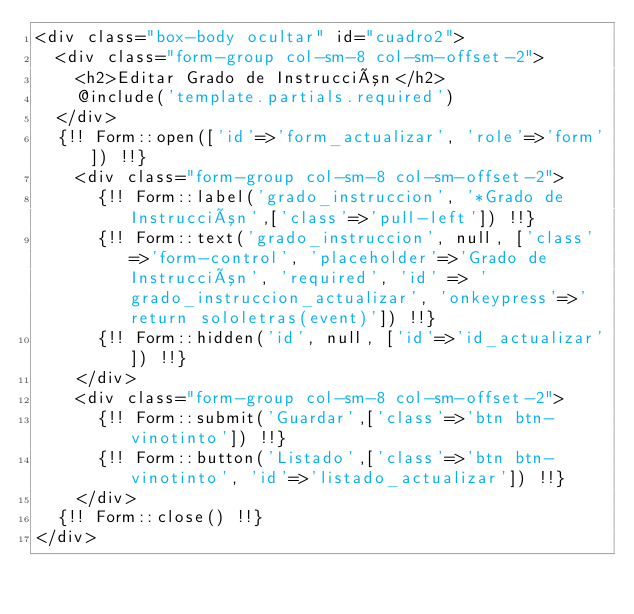Convert code to text. <code><loc_0><loc_0><loc_500><loc_500><_PHP_><div class="box-body ocultar" id="cuadro2">
  <div class="form-group col-sm-8 col-sm-offset-2">
    <h2>Editar Grado de Instrucción</h2>
    @include('template.partials.required')
  </div>
  {!! Form::open(['id'=>'form_actualizar', 'role'=>'form']) !!}
    <div class="form-group col-sm-8 col-sm-offset-2">
      {!! Form::label('grado_instruccion', '*Grado de Instrucción',['class'=>'pull-left']) !!}
      {!! Form::text('grado_instruccion', null, ['class'=>'form-control', 'placeholder'=>'Grado de Instrucción', 'required', 'id' => 'grado_instruccion_actualizar', 'onkeypress'=>'return sololetras(event)']) !!}
      {!! Form::hidden('id', null, ['id'=>'id_actualizar']) !!}
    </div>
    <div class="form-group col-sm-8 col-sm-offset-2">
      {!! Form::submit('Guardar',['class'=>'btn btn-vinotinto']) !!}
      {!! Form::button('Listado',['class'=>'btn btn-vinotinto', 'id'=>'listado_actualizar']) !!}
    </div>
  {!! Form::close() !!}
</div></code> 